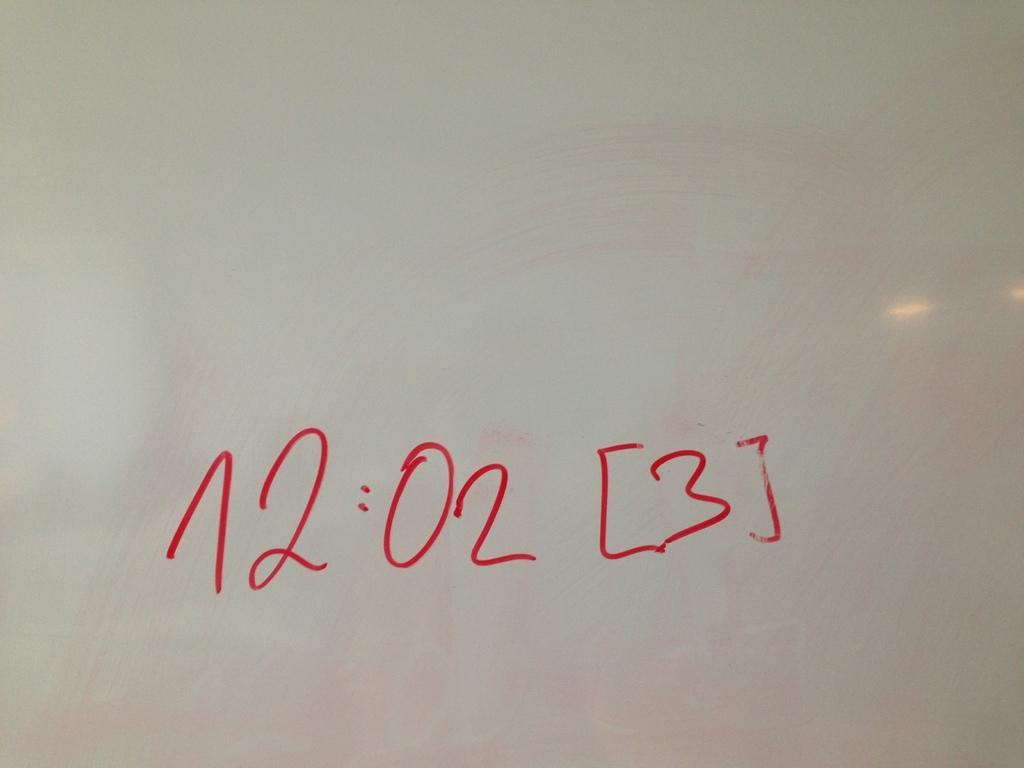<image>
Present a compact description of the photo's key features. The number sequence 12:02 [3] is written in red marker on a whiteboard. 